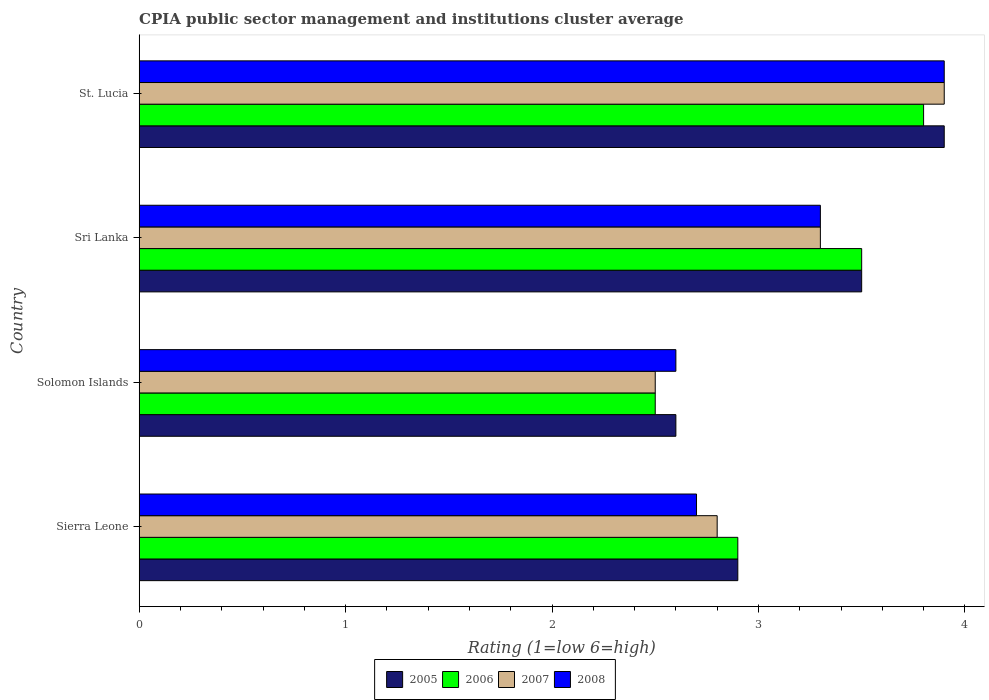How many groups of bars are there?
Keep it short and to the point. 4. Are the number of bars per tick equal to the number of legend labels?
Provide a short and direct response. Yes. How many bars are there on the 4th tick from the top?
Your response must be concise. 4. How many bars are there on the 3rd tick from the bottom?
Keep it short and to the point. 4. What is the label of the 3rd group of bars from the top?
Make the answer very short. Solomon Islands. In how many cases, is the number of bars for a given country not equal to the number of legend labels?
Provide a short and direct response. 0. Across all countries, what is the minimum CPIA rating in 2008?
Make the answer very short. 2.6. In which country was the CPIA rating in 2007 maximum?
Offer a very short reply. St. Lucia. In which country was the CPIA rating in 2006 minimum?
Your answer should be very brief. Solomon Islands. What is the total CPIA rating in 2008 in the graph?
Provide a succinct answer. 12.5. What is the difference between the CPIA rating in 2006 in St. Lucia and the CPIA rating in 2007 in Solomon Islands?
Give a very brief answer. 1.3. What is the average CPIA rating in 2007 per country?
Your answer should be very brief. 3.12. What is the difference between the CPIA rating in 2006 and CPIA rating in 2005 in St. Lucia?
Keep it short and to the point. -0.1. What is the ratio of the CPIA rating in 2005 in Sierra Leone to that in St. Lucia?
Offer a very short reply. 0.74. Is the difference between the CPIA rating in 2006 in Solomon Islands and Sri Lanka greater than the difference between the CPIA rating in 2005 in Solomon Islands and Sri Lanka?
Offer a very short reply. No. What is the difference between the highest and the second highest CPIA rating in 2008?
Your answer should be very brief. 0.6. What is the difference between the highest and the lowest CPIA rating in 2007?
Your response must be concise. 1.4. What does the 3rd bar from the top in Solomon Islands represents?
Provide a succinct answer. 2006. What does the 3rd bar from the bottom in Sri Lanka represents?
Your answer should be compact. 2007. Are all the bars in the graph horizontal?
Your answer should be very brief. Yes. What is the difference between two consecutive major ticks on the X-axis?
Your answer should be very brief. 1. Does the graph contain grids?
Give a very brief answer. No. Where does the legend appear in the graph?
Your answer should be compact. Bottom center. What is the title of the graph?
Ensure brevity in your answer.  CPIA public sector management and institutions cluster average. What is the label or title of the Y-axis?
Provide a short and direct response. Country. What is the Rating (1=low 6=high) of 2005 in Sierra Leone?
Your answer should be very brief. 2.9. What is the Rating (1=low 6=high) of 2007 in Sierra Leone?
Provide a succinct answer. 2.8. What is the Rating (1=low 6=high) in 2006 in Solomon Islands?
Your answer should be very brief. 2.5. What is the Rating (1=low 6=high) in 2007 in Solomon Islands?
Provide a succinct answer. 2.5. What is the Rating (1=low 6=high) in 2006 in St. Lucia?
Your response must be concise. 3.8. What is the Rating (1=low 6=high) of 2007 in St. Lucia?
Your answer should be very brief. 3.9. What is the Rating (1=low 6=high) of 2008 in St. Lucia?
Offer a very short reply. 3.9. Across all countries, what is the maximum Rating (1=low 6=high) in 2005?
Keep it short and to the point. 3.9. Across all countries, what is the maximum Rating (1=low 6=high) in 2006?
Offer a terse response. 3.8. Across all countries, what is the maximum Rating (1=low 6=high) in 2008?
Ensure brevity in your answer.  3.9. Across all countries, what is the minimum Rating (1=low 6=high) of 2005?
Offer a very short reply. 2.6. Across all countries, what is the minimum Rating (1=low 6=high) of 2008?
Your response must be concise. 2.6. What is the total Rating (1=low 6=high) in 2005 in the graph?
Your answer should be very brief. 12.9. What is the total Rating (1=low 6=high) of 2006 in the graph?
Keep it short and to the point. 12.7. What is the total Rating (1=low 6=high) in 2007 in the graph?
Keep it short and to the point. 12.5. What is the difference between the Rating (1=low 6=high) in 2006 in Sierra Leone and that in Solomon Islands?
Your response must be concise. 0.4. What is the difference between the Rating (1=low 6=high) in 2007 in Sierra Leone and that in Solomon Islands?
Offer a terse response. 0.3. What is the difference between the Rating (1=low 6=high) in 2008 in Sierra Leone and that in Solomon Islands?
Your answer should be very brief. 0.1. What is the difference between the Rating (1=low 6=high) of 2005 in Sierra Leone and that in Sri Lanka?
Offer a terse response. -0.6. What is the difference between the Rating (1=low 6=high) in 2008 in Sierra Leone and that in Sri Lanka?
Provide a short and direct response. -0.6. What is the difference between the Rating (1=low 6=high) of 2006 in Sierra Leone and that in St. Lucia?
Make the answer very short. -0.9. What is the difference between the Rating (1=low 6=high) in 2008 in Sierra Leone and that in St. Lucia?
Offer a very short reply. -1.2. What is the difference between the Rating (1=low 6=high) of 2007 in Solomon Islands and that in Sri Lanka?
Your answer should be compact. -0.8. What is the difference between the Rating (1=low 6=high) in 2008 in Solomon Islands and that in Sri Lanka?
Ensure brevity in your answer.  -0.7. What is the difference between the Rating (1=low 6=high) in 2005 in Solomon Islands and that in St. Lucia?
Your response must be concise. -1.3. What is the difference between the Rating (1=low 6=high) in 2006 in Solomon Islands and that in St. Lucia?
Your answer should be compact. -1.3. What is the difference between the Rating (1=low 6=high) of 2007 in Solomon Islands and that in St. Lucia?
Keep it short and to the point. -1.4. What is the difference between the Rating (1=low 6=high) of 2005 in Sri Lanka and that in St. Lucia?
Offer a very short reply. -0.4. What is the difference between the Rating (1=low 6=high) of 2007 in Sri Lanka and that in St. Lucia?
Your answer should be very brief. -0.6. What is the difference between the Rating (1=low 6=high) of 2008 in Sri Lanka and that in St. Lucia?
Provide a succinct answer. -0.6. What is the difference between the Rating (1=low 6=high) of 2005 in Sierra Leone and the Rating (1=low 6=high) of 2006 in Solomon Islands?
Your answer should be compact. 0.4. What is the difference between the Rating (1=low 6=high) in 2005 in Sierra Leone and the Rating (1=low 6=high) in 2007 in Solomon Islands?
Offer a very short reply. 0.4. What is the difference between the Rating (1=low 6=high) in 2005 in Sierra Leone and the Rating (1=low 6=high) in 2008 in Solomon Islands?
Keep it short and to the point. 0.3. What is the difference between the Rating (1=low 6=high) of 2006 in Sierra Leone and the Rating (1=low 6=high) of 2007 in Solomon Islands?
Give a very brief answer. 0.4. What is the difference between the Rating (1=low 6=high) in 2006 in Sierra Leone and the Rating (1=low 6=high) in 2008 in Solomon Islands?
Your answer should be very brief. 0.3. What is the difference between the Rating (1=low 6=high) of 2007 in Sierra Leone and the Rating (1=low 6=high) of 2008 in Solomon Islands?
Provide a succinct answer. 0.2. What is the difference between the Rating (1=low 6=high) in 2005 in Sierra Leone and the Rating (1=low 6=high) in 2006 in Sri Lanka?
Ensure brevity in your answer.  -0.6. What is the difference between the Rating (1=low 6=high) in 2005 in Sierra Leone and the Rating (1=low 6=high) in 2008 in Sri Lanka?
Your answer should be very brief. -0.4. What is the difference between the Rating (1=low 6=high) of 2006 in Sierra Leone and the Rating (1=low 6=high) of 2007 in Sri Lanka?
Give a very brief answer. -0.4. What is the difference between the Rating (1=low 6=high) in 2007 in Sierra Leone and the Rating (1=low 6=high) in 2008 in Sri Lanka?
Your answer should be compact. -0.5. What is the difference between the Rating (1=low 6=high) of 2005 in Solomon Islands and the Rating (1=low 6=high) of 2007 in Sri Lanka?
Your response must be concise. -0.7. What is the difference between the Rating (1=low 6=high) of 2005 in Solomon Islands and the Rating (1=low 6=high) of 2008 in Sri Lanka?
Your answer should be very brief. -0.7. What is the difference between the Rating (1=low 6=high) of 2006 in Solomon Islands and the Rating (1=low 6=high) of 2007 in Sri Lanka?
Your response must be concise. -0.8. What is the difference between the Rating (1=low 6=high) in 2006 in Solomon Islands and the Rating (1=low 6=high) in 2007 in St. Lucia?
Offer a terse response. -1.4. What is the difference between the Rating (1=low 6=high) in 2005 in Sri Lanka and the Rating (1=low 6=high) in 2006 in St. Lucia?
Offer a very short reply. -0.3. What is the difference between the Rating (1=low 6=high) in 2006 in Sri Lanka and the Rating (1=low 6=high) in 2007 in St. Lucia?
Provide a succinct answer. -0.4. What is the difference between the Rating (1=low 6=high) in 2006 in Sri Lanka and the Rating (1=low 6=high) in 2008 in St. Lucia?
Offer a terse response. -0.4. What is the average Rating (1=low 6=high) in 2005 per country?
Provide a succinct answer. 3.23. What is the average Rating (1=low 6=high) of 2006 per country?
Ensure brevity in your answer.  3.17. What is the average Rating (1=low 6=high) in 2007 per country?
Make the answer very short. 3.12. What is the average Rating (1=low 6=high) of 2008 per country?
Offer a very short reply. 3.12. What is the difference between the Rating (1=low 6=high) in 2005 and Rating (1=low 6=high) in 2006 in Sierra Leone?
Keep it short and to the point. 0. What is the difference between the Rating (1=low 6=high) in 2005 and Rating (1=low 6=high) in 2008 in Sierra Leone?
Offer a very short reply. 0.2. What is the difference between the Rating (1=low 6=high) in 2006 and Rating (1=low 6=high) in 2007 in Sierra Leone?
Offer a very short reply. 0.1. What is the difference between the Rating (1=low 6=high) of 2005 and Rating (1=low 6=high) of 2006 in Solomon Islands?
Keep it short and to the point. 0.1. What is the difference between the Rating (1=low 6=high) of 2005 and Rating (1=low 6=high) of 2007 in Solomon Islands?
Your answer should be very brief. 0.1. What is the difference between the Rating (1=low 6=high) in 2005 and Rating (1=low 6=high) in 2008 in Solomon Islands?
Offer a terse response. 0. What is the difference between the Rating (1=low 6=high) in 2006 and Rating (1=low 6=high) in 2008 in Solomon Islands?
Ensure brevity in your answer.  -0.1. What is the difference between the Rating (1=low 6=high) in 2005 and Rating (1=low 6=high) in 2006 in Sri Lanka?
Your answer should be very brief. 0. What is the difference between the Rating (1=low 6=high) in 2007 and Rating (1=low 6=high) in 2008 in Sri Lanka?
Keep it short and to the point. 0. What is the difference between the Rating (1=low 6=high) in 2005 and Rating (1=low 6=high) in 2006 in St. Lucia?
Offer a very short reply. 0.1. What is the difference between the Rating (1=low 6=high) of 2006 and Rating (1=low 6=high) of 2007 in St. Lucia?
Make the answer very short. -0.1. What is the ratio of the Rating (1=low 6=high) of 2005 in Sierra Leone to that in Solomon Islands?
Your answer should be very brief. 1.12. What is the ratio of the Rating (1=low 6=high) of 2006 in Sierra Leone to that in Solomon Islands?
Provide a succinct answer. 1.16. What is the ratio of the Rating (1=low 6=high) of 2007 in Sierra Leone to that in Solomon Islands?
Make the answer very short. 1.12. What is the ratio of the Rating (1=low 6=high) of 2005 in Sierra Leone to that in Sri Lanka?
Ensure brevity in your answer.  0.83. What is the ratio of the Rating (1=low 6=high) in 2006 in Sierra Leone to that in Sri Lanka?
Your answer should be compact. 0.83. What is the ratio of the Rating (1=low 6=high) in 2007 in Sierra Leone to that in Sri Lanka?
Provide a short and direct response. 0.85. What is the ratio of the Rating (1=low 6=high) of 2008 in Sierra Leone to that in Sri Lanka?
Your response must be concise. 0.82. What is the ratio of the Rating (1=low 6=high) in 2005 in Sierra Leone to that in St. Lucia?
Make the answer very short. 0.74. What is the ratio of the Rating (1=low 6=high) in 2006 in Sierra Leone to that in St. Lucia?
Make the answer very short. 0.76. What is the ratio of the Rating (1=low 6=high) of 2007 in Sierra Leone to that in St. Lucia?
Make the answer very short. 0.72. What is the ratio of the Rating (1=low 6=high) of 2008 in Sierra Leone to that in St. Lucia?
Your answer should be compact. 0.69. What is the ratio of the Rating (1=low 6=high) of 2005 in Solomon Islands to that in Sri Lanka?
Give a very brief answer. 0.74. What is the ratio of the Rating (1=low 6=high) in 2007 in Solomon Islands to that in Sri Lanka?
Give a very brief answer. 0.76. What is the ratio of the Rating (1=low 6=high) of 2008 in Solomon Islands to that in Sri Lanka?
Offer a very short reply. 0.79. What is the ratio of the Rating (1=low 6=high) of 2005 in Solomon Islands to that in St. Lucia?
Provide a succinct answer. 0.67. What is the ratio of the Rating (1=low 6=high) in 2006 in Solomon Islands to that in St. Lucia?
Make the answer very short. 0.66. What is the ratio of the Rating (1=low 6=high) in 2007 in Solomon Islands to that in St. Lucia?
Keep it short and to the point. 0.64. What is the ratio of the Rating (1=low 6=high) of 2008 in Solomon Islands to that in St. Lucia?
Keep it short and to the point. 0.67. What is the ratio of the Rating (1=low 6=high) in 2005 in Sri Lanka to that in St. Lucia?
Your answer should be compact. 0.9. What is the ratio of the Rating (1=low 6=high) of 2006 in Sri Lanka to that in St. Lucia?
Offer a very short reply. 0.92. What is the ratio of the Rating (1=low 6=high) of 2007 in Sri Lanka to that in St. Lucia?
Give a very brief answer. 0.85. What is the ratio of the Rating (1=low 6=high) in 2008 in Sri Lanka to that in St. Lucia?
Offer a terse response. 0.85. What is the difference between the highest and the second highest Rating (1=low 6=high) in 2005?
Offer a terse response. 0.4. What is the difference between the highest and the second highest Rating (1=low 6=high) in 2007?
Your answer should be very brief. 0.6. What is the difference between the highest and the second highest Rating (1=low 6=high) of 2008?
Your answer should be very brief. 0.6. What is the difference between the highest and the lowest Rating (1=low 6=high) of 2005?
Provide a succinct answer. 1.3. What is the difference between the highest and the lowest Rating (1=low 6=high) in 2007?
Provide a succinct answer. 1.4. What is the difference between the highest and the lowest Rating (1=low 6=high) of 2008?
Make the answer very short. 1.3. 